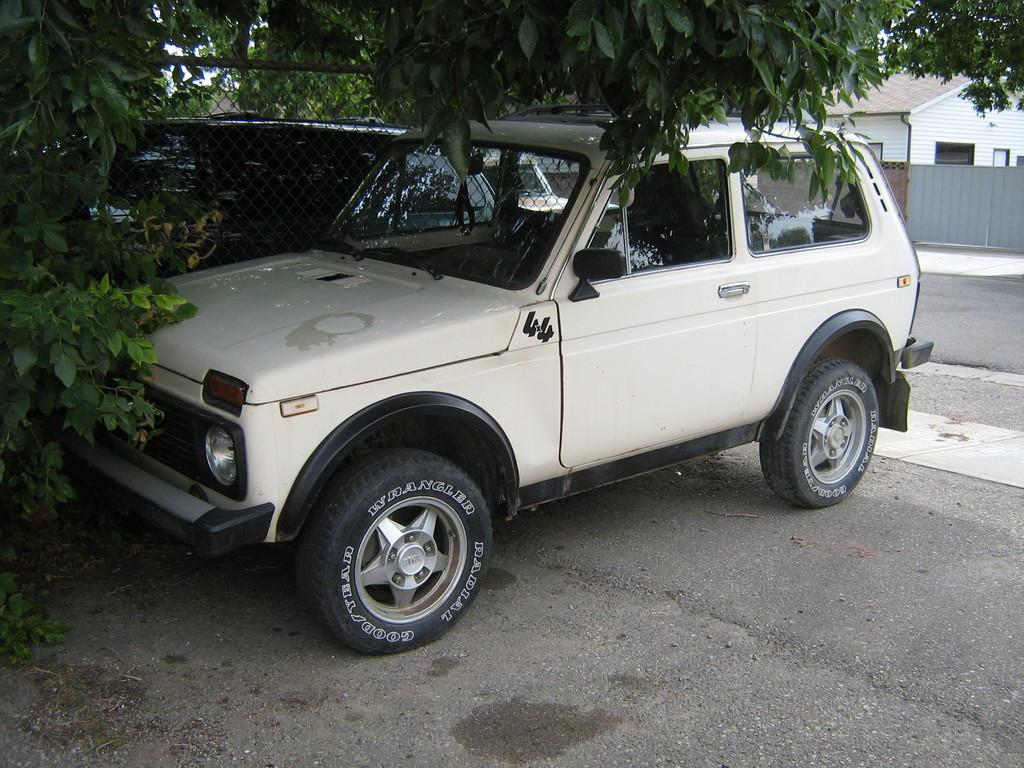What can be seen parked on the ground in the image? There are vehicles parked on the ground in the image. What type of natural elements are visible in the image? There are trees visible in the image. What type of structure is located at the back of the image? There is a house at the back of the image. What is associated with the house in the image? There is a gate associated with the house. What is the interest rate of the house in the image? There is no information about the interest rate of the house in the image. Can you tell me how many people are walking in the image? There is no information about people walking in the image; it only shows vehicles parked on the ground, trees, a house, and a gate. 